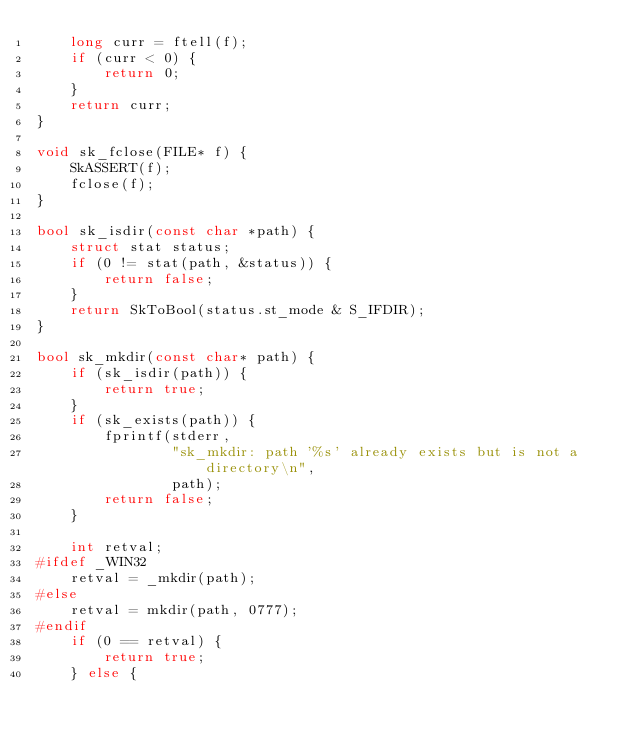Convert code to text. <code><loc_0><loc_0><loc_500><loc_500><_C++_>    long curr = ftell(f);
    if (curr < 0) {
        return 0;
    }
    return curr;
}

void sk_fclose(FILE* f) {
    SkASSERT(f);
    fclose(f);
}

bool sk_isdir(const char *path) {
    struct stat status;
    if (0 != stat(path, &status)) {
        return false;
    }
    return SkToBool(status.st_mode & S_IFDIR);
}

bool sk_mkdir(const char* path) {
    if (sk_isdir(path)) {
        return true;
    }
    if (sk_exists(path)) {
        fprintf(stderr,
                "sk_mkdir: path '%s' already exists but is not a directory\n",
                path);
        return false;
    }

    int retval;
#ifdef _WIN32
    retval = _mkdir(path);
#else
    retval = mkdir(path, 0777);
#endif
    if (0 == retval) {
        return true;
    } else {</code> 